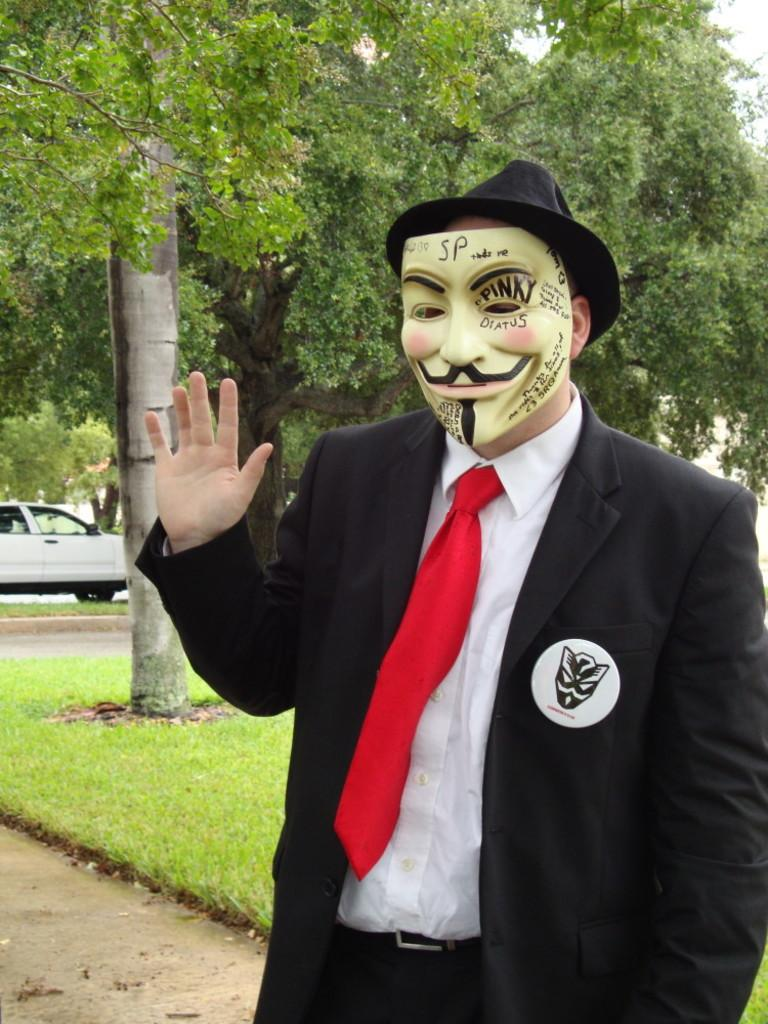What is the person in the foreground of the image wearing? The person in the foreground of the image is wearing a mask. What can be seen in the middle of the image? There are trees, a car, grass, and a path in the middle of the image. What is visible in the top right corner of the image? The sky is visible in the top right corner of the image. What scent is emanating from the trees in the image? There is no information about the scent of the trees in the image, as it is not mentioned in the provided facts. 